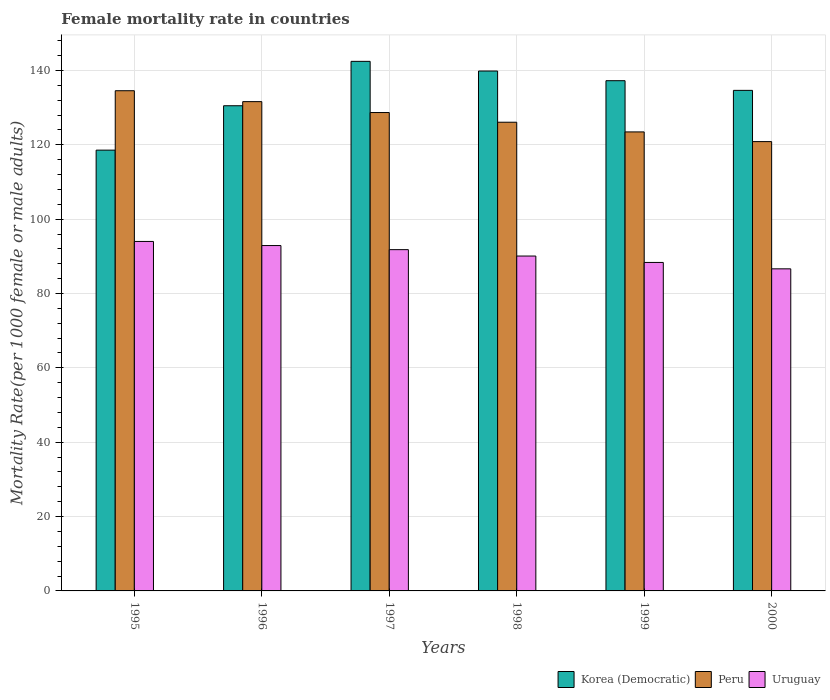How many different coloured bars are there?
Your response must be concise. 3. How many groups of bars are there?
Your answer should be compact. 6. Are the number of bars per tick equal to the number of legend labels?
Make the answer very short. Yes. How many bars are there on the 5th tick from the right?
Your answer should be compact. 3. What is the label of the 1st group of bars from the left?
Give a very brief answer. 1995. In how many cases, is the number of bars for a given year not equal to the number of legend labels?
Make the answer very short. 0. What is the female mortality rate in Peru in 1996?
Ensure brevity in your answer.  131.61. Across all years, what is the maximum female mortality rate in Peru?
Give a very brief answer. 134.54. Across all years, what is the minimum female mortality rate in Peru?
Give a very brief answer. 120.86. In which year was the female mortality rate in Korea (Democratic) maximum?
Give a very brief answer. 1997. In which year was the female mortality rate in Korea (Democratic) minimum?
Offer a terse response. 1995. What is the total female mortality rate in Korea (Democratic) in the graph?
Your answer should be very brief. 803.24. What is the difference between the female mortality rate in Uruguay in 1998 and that in 1999?
Provide a succinct answer. 1.72. What is the difference between the female mortality rate in Korea (Democratic) in 2000 and the female mortality rate in Peru in 1996?
Your answer should be very brief. 3.03. What is the average female mortality rate in Peru per year?
Make the answer very short. 127.54. In the year 1995, what is the difference between the female mortality rate in Korea (Democratic) and female mortality rate in Uruguay?
Provide a succinct answer. 24.56. What is the ratio of the female mortality rate in Uruguay in 1997 to that in 1998?
Provide a succinct answer. 1.02. Is the female mortality rate in Uruguay in 1995 less than that in 1997?
Provide a succinct answer. No. Is the difference between the female mortality rate in Korea (Democratic) in 1995 and 1998 greater than the difference between the female mortality rate in Uruguay in 1995 and 1998?
Your answer should be compact. No. What is the difference between the highest and the second highest female mortality rate in Uruguay?
Make the answer very short. 1.1. What is the difference between the highest and the lowest female mortality rate in Korea (Democratic)?
Offer a very short reply. 23.88. In how many years, is the female mortality rate in Uruguay greater than the average female mortality rate in Uruguay taken over all years?
Give a very brief answer. 3. Is the sum of the female mortality rate in Peru in 1995 and 2000 greater than the maximum female mortality rate in Uruguay across all years?
Make the answer very short. Yes. How many bars are there?
Provide a succinct answer. 18. Are the values on the major ticks of Y-axis written in scientific E-notation?
Give a very brief answer. No. Where does the legend appear in the graph?
Provide a succinct answer. Bottom right. What is the title of the graph?
Keep it short and to the point. Female mortality rate in countries. Does "Iraq" appear as one of the legend labels in the graph?
Your response must be concise. No. What is the label or title of the X-axis?
Provide a short and direct response. Years. What is the label or title of the Y-axis?
Offer a terse response. Mortality Rate(per 1000 female or male adults). What is the Mortality Rate(per 1000 female or male adults) of Korea (Democratic) in 1995?
Give a very brief answer. 118.56. What is the Mortality Rate(per 1000 female or male adults) in Peru in 1995?
Give a very brief answer. 134.54. What is the Mortality Rate(per 1000 female or male adults) of Uruguay in 1995?
Offer a terse response. 94. What is the Mortality Rate(per 1000 female or male adults) in Korea (Democratic) in 1996?
Your response must be concise. 130.5. What is the Mortality Rate(per 1000 female or male adults) in Peru in 1996?
Make the answer very short. 131.61. What is the Mortality Rate(per 1000 female or male adults) in Uruguay in 1996?
Your response must be concise. 92.9. What is the Mortality Rate(per 1000 female or male adults) in Korea (Democratic) in 1997?
Offer a terse response. 142.44. What is the Mortality Rate(per 1000 female or male adults) of Peru in 1997?
Provide a short and direct response. 128.68. What is the Mortality Rate(per 1000 female or male adults) of Uruguay in 1997?
Make the answer very short. 91.8. What is the Mortality Rate(per 1000 female or male adults) of Korea (Democratic) in 1998?
Your response must be concise. 139.84. What is the Mortality Rate(per 1000 female or male adults) in Peru in 1998?
Make the answer very short. 126.07. What is the Mortality Rate(per 1000 female or male adults) in Uruguay in 1998?
Keep it short and to the point. 90.08. What is the Mortality Rate(per 1000 female or male adults) in Korea (Democratic) in 1999?
Ensure brevity in your answer.  137.24. What is the Mortality Rate(per 1000 female or male adults) of Peru in 1999?
Provide a succinct answer. 123.47. What is the Mortality Rate(per 1000 female or male adults) of Uruguay in 1999?
Give a very brief answer. 88.36. What is the Mortality Rate(per 1000 female or male adults) in Korea (Democratic) in 2000?
Keep it short and to the point. 134.64. What is the Mortality Rate(per 1000 female or male adults) in Peru in 2000?
Your answer should be compact. 120.86. What is the Mortality Rate(per 1000 female or male adults) of Uruguay in 2000?
Keep it short and to the point. 86.64. Across all years, what is the maximum Mortality Rate(per 1000 female or male adults) in Korea (Democratic)?
Give a very brief answer. 142.44. Across all years, what is the maximum Mortality Rate(per 1000 female or male adults) of Peru?
Give a very brief answer. 134.54. Across all years, what is the maximum Mortality Rate(per 1000 female or male adults) in Uruguay?
Your answer should be very brief. 94. Across all years, what is the minimum Mortality Rate(per 1000 female or male adults) of Korea (Democratic)?
Provide a short and direct response. 118.56. Across all years, what is the minimum Mortality Rate(per 1000 female or male adults) in Peru?
Give a very brief answer. 120.86. Across all years, what is the minimum Mortality Rate(per 1000 female or male adults) of Uruguay?
Offer a very short reply. 86.64. What is the total Mortality Rate(per 1000 female or male adults) of Korea (Democratic) in the graph?
Your answer should be very brief. 803.24. What is the total Mortality Rate(per 1000 female or male adults) of Peru in the graph?
Your response must be concise. 765.23. What is the total Mortality Rate(per 1000 female or male adults) in Uruguay in the graph?
Your answer should be very brief. 543.76. What is the difference between the Mortality Rate(per 1000 female or male adults) of Korea (Democratic) in 1995 and that in 1996?
Your answer should be compact. -11.94. What is the difference between the Mortality Rate(per 1000 female or male adults) of Peru in 1995 and that in 1996?
Offer a very short reply. 2.93. What is the difference between the Mortality Rate(per 1000 female or male adults) of Uruguay in 1995 and that in 1996?
Your answer should be compact. 1.1. What is the difference between the Mortality Rate(per 1000 female or male adults) of Korea (Democratic) in 1995 and that in 1997?
Your response must be concise. -23.88. What is the difference between the Mortality Rate(per 1000 female or male adults) of Peru in 1995 and that in 1997?
Keep it short and to the point. 5.87. What is the difference between the Mortality Rate(per 1000 female or male adults) in Uruguay in 1995 and that in 1997?
Ensure brevity in your answer.  2.21. What is the difference between the Mortality Rate(per 1000 female or male adults) in Korea (Democratic) in 1995 and that in 1998?
Ensure brevity in your answer.  -21.28. What is the difference between the Mortality Rate(per 1000 female or male adults) of Peru in 1995 and that in 1998?
Your response must be concise. 8.47. What is the difference between the Mortality Rate(per 1000 female or male adults) in Uruguay in 1995 and that in 1998?
Provide a succinct answer. 3.93. What is the difference between the Mortality Rate(per 1000 female or male adults) in Korea (Democratic) in 1995 and that in 1999?
Offer a terse response. -18.68. What is the difference between the Mortality Rate(per 1000 female or male adults) in Peru in 1995 and that in 1999?
Your answer should be very brief. 11.08. What is the difference between the Mortality Rate(per 1000 female or male adults) of Uruguay in 1995 and that in 1999?
Offer a terse response. 5.65. What is the difference between the Mortality Rate(per 1000 female or male adults) in Korea (Democratic) in 1995 and that in 2000?
Offer a very short reply. -16.08. What is the difference between the Mortality Rate(per 1000 female or male adults) of Peru in 1995 and that in 2000?
Make the answer very short. 13.68. What is the difference between the Mortality Rate(per 1000 female or male adults) of Uruguay in 1995 and that in 2000?
Give a very brief answer. 7.37. What is the difference between the Mortality Rate(per 1000 female or male adults) in Korea (Democratic) in 1996 and that in 1997?
Keep it short and to the point. -11.94. What is the difference between the Mortality Rate(per 1000 female or male adults) in Peru in 1996 and that in 1997?
Offer a terse response. 2.93. What is the difference between the Mortality Rate(per 1000 female or male adults) of Uruguay in 1996 and that in 1997?
Give a very brief answer. 1.1. What is the difference between the Mortality Rate(per 1000 female or male adults) in Korea (Democratic) in 1996 and that in 1998?
Ensure brevity in your answer.  -9.34. What is the difference between the Mortality Rate(per 1000 female or male adults) of Peru in 1996 and that in 1998?
Provide a short and direct response. 5.54. What is the difference between the Mortality Rate(per 1000 female or male adults) in Uruguay in 1996 and that in 1998?
Make the answer very short. 2.82. What is the difference between the Mortality Rate(per 1000 female or male adults) of Korea (Democratic) in 1996 and that in 1999?
Your answer should be very brief. -6.74. What is the difference between the Mortality Rate(per 1000 female or male adults) of Peru in 1996 and that in 1999?
Your answer should be very brief. 8.14. What is the difference between the Mortality Rate(per 1000 female or male adults) of Uruguay in 1996 and that in 1999?
Offer a terse response. 4.54. What is the difference between the Mortality Rate(per 1000 female or male adults) of Korea (Democratic) in 1996 and that in 2000?
Your response must be concise. -4.14. What is the difference between the Mortality Rate(per 1000 female or male adults) of Peru in 1996 and that in 2000?
Keep it short and to the point. 10.75. What is the difference between the Mortality Rate(per 1000 female or male adults) of Uruguay in 1996 and that in 2000?
Give a very brief answer. 6.26. What is the difference between the Mortality Rate(per 1000 female or male adults) of Korea (Democratic) in 1997 and that in 1998?
Your answer should be very brief. 2.6. What is the difference between the Mortality Rate(per 1000 female or male adults) in Peru in 1997 and that in 1998?
Provide a short and direct response. 2.6. What is the difference between the Mortality Rate(per 1000 female or male adults) in Uruguay in 1997 and that in 1998?
Your answer should be very brief. 1.72. What is the difference between the Mortality Rate(per 1000 female or male adults) in Korea (Democratic) in 1997 and that in 1999?
Give a very brief answer. 5.2. What is the difference between the Mortality Rate(per 1000 female or male adults) of Peru in 1997 and that in 1999?
Provide a short and direct response. 5.21. What is the difference between the Mortality Rate(per 1000 female or male adults) of Uruguay in 1997 and that in 1999?
Your answer should be compact. 3.44. What is the difference between the Mortality Rate(per 1000 female or male adults) of Korea (Democratic) in 1997 and that in 2000?
Your answer should be very brief. 7.8. What is the difference between the Mortality Rate(per 1000 female or male adults) in Peru in 1997 and that in 2000?
Give a very brief answer. 7.82. What is the difference between the Mortality Rate(per 1000 female or male adults) of Uruguay in 1997 and that in 2000?
Your answer should be compact. 5.16. What is the difference between the Mortality Rate(per 1000 female or male adults) in Korea (Democratic) in 1998 and that in 1999?
Ensure brevity in your answer.  2.6. What is the difference between the Mortality Rate(per 1000 female or male adults) in Peru in 1998 and that in 1999?
Offer a terse response. 2.61. What is the difference between the Mortality Rate(per 1000 female or male adults) of Uruguay in 1998 and that in 1999?
Your response must be concise. 1.72. What is the difference between the Mortality Rate(per 1000 female or male adults) in Korea (Democratic) in 1998 and that in 2000?
Your answer should be very brief. 5.2. What is the difference between the Mortality Rate(per 1000 female or male adults) of Peru in 1998 and that in 2000?
Provide a short and direct response. 5.21. What is the difference between the Mortality Rate(per 1000 female or male adults) in Uruguay in 1998 and that in 2000?
Your response must be concise. 3.44. What is the difference between the Mortality Rate(per 1000 female or male adults) in Korea (Democratic) in 1999 and that in 2000?
Your response must be concise. 2.6. What is the difference between the Mortality Rate(per 1000 female or male adults) of Peru in 1999 and that in 2000?
Give a very brief answer. 2.6. What is the difference between the Mortality Rate(per 1000 female or male adults) in Uruguay in 1999 and that in 2000?
Your answer should be very brief. 1.72. What is the difference between the Mortality Rate(per 1000 female or male adults) of Korea (Democratic) in 1995 and the Mortality Rate(per 1000 female or male adults) of Peru in 1996?
Ensure brevity in your answer.  -13.04. What is the difference between the Mortality Rate(per 1000 female or male adults) in Korea (Democratic) in 1995 and the Mortality Rate(per 1000 female or male adults) in Uruguay in 1996?
Your response must be concise. 25.67. What is the difference between the Mortality Rate(per 1000 female or male adults) of Peru in 1995 and the Mortality Rate(per 1000 female or male adults) of Uruguay in 1996?
Keep it short and to the point. 41.65. What is the difference between the Mortality Rate(per 1000 female or male adults) of Korea (Democratic) in 1995 and the Mortality Rate(per 1000 female or male adults) of Peru in 1997?
Offer a terse response. -10.11. What is the difference between the Mortality Rate(per 1000 female or male adults) of Korea (Democratic) in 1995 and the Mortality Rate(per 1000 female or male adults) of Uruguay in 1997?
Provide a succinct answer. 26.77. What is the difference between the Mortality Rate(per 1000 female or male adults) of Peru in 1995 and the Mortality Rate(per 1000 female or male adults) of Uruguay in 1997?
Your response must be concise. 42.75. What is the difference between the Mortality Rate(per 1000 female or male adults) in Korea (Democratic) in 1995 and the Mortality Rate(per 1000 female or male adults) in Peru in 1998?
Make the answer very short. -7.51. What is the difference between the Mortality Rate(per 1000 female or male adults) in Korea (Democratic) in 1995 and the Mortality Rate(per 1000 female or male adults) in Uruguay in 1998?
Your answer should be compact. 28.49. What is the difference between the Mortality Rate(per 1000 female or male adults) of Peru in 1995 and the Mortality Rate(per 1000 female or male adults) of Uruguay in 1998?
Your answer should be compact. 44.47. What is the difference between the Mortality Rate(per 1000 female or male adults) of Korea (Democratic) in 1995 and the Mortality Rate(per 1000 female or male adults) of Peru in 1999?
Your answer should be very brief. -4.9. What is the difference between the Mortality Rate(per 1000 female or male adults) of Korea (Democratic) in 1995 and the Mortality Rate(per 1000 female or male adults) of Uruguay in 1999?
Your answer should be compact. 30.21. What is the difference between the Mortality Rate(per 1000 female or male adults) in Peru in 1995 and the Mortality Rate(per 1000 female or male adults) in Uruguay in 1999?
Give a very brief answer. 46.19. What is the difference between the Mortality Rate(per 1000 female or male adults) of Korea (Democratic) in 1995 and the Mortality Rate(per 1000 female or male adults) of Peru in 2000?
Ensure brevity in your answer.  -2.29. What is the difference between the Mortality Rate(per 1000 female or male adults) in Korea (Democratic) in 1995 and the Mortality Rate(per 1000 female or male adults) in Uruguay in 2000?
Offer a terse response. 31.93. What is the difference between the Mortality Rate(per 1000 female or male adults) in Peru in 1995 and the Mortality Rate(per 1000 female or male adults) in Uruguay in 2000?
Provide a succinct answer. 47.91. What is the difference between the Mortality Rate(per 1000 female or male adults) of Korea (Democratic) in 1996 and the Mortality Rate(per 1000 female or male adults) of Peru in 1997?
Your answer should be very brief. 1.83. What is the difference between the Mortality Rate(per 1000 female or male adults) of Korea (Democratic) in 1996 and the Mortality Rate(per 1000 female or male adults) of Uruguay in 1997?
Keep it short and to the point. 38.71. What is the difference between the Mortality Rate(per 1000 female or male adults) of Peru in 1996 and the Mortality Rate(per 1000 female or male adults) of Uruguay in 1997?
Provide a succinct answer. 39.81. What is the difference between the Mortality Rate(per 1000 female or male adults) in Korea (Democratic) in 1996 and the Mortality Rate(per 1000 female or male adults) in Peru in 1998?
Keep it short and to the point. 4.43. What is the difference between the Mortality Rate(per 1000 female or male adults) in Korea (Democratic) in 1996 and the Mortality Rate(per 1000 female or male adults) in Uruguay in 1998?
Offer a very short reply. 40.43. What is the difference between the Mortality Rate(per 1000 female or male adults) in Peru in 1996 and the Mortality Rate(per 1000 female or male adults) in Uruguay in 1998?
Make the answer very short. 41.53. What is the difference between the Mortality Rate(per 1000 female or male adults) in Korea (Democratic) in 1996 and the Mortality Rate(per 1000 female or male adults) in Peru in 1999?
Offer a terse response. 7.04. What is the difference between the Mortality Rate(per 1000 female or male adults) of Korea (Democratic) in 1996 and the Mortality Rate(per 1000 female or male adults) of Uruguay in 1999?
Offer a very short reply. 42.15. What is the difference between the Mortality Rate(per 1000 female or male adults) of Peru in 1996 and the Mortality Rate(per 1000 female or male adults) of Uruguay in 1999?
Provide a short and direct response. 43.25. What is the difference between the Mortality Rate(per 1000 female or male adults) in Korea (Democratic) in 1996 and the Mortality Rate(per 1000 female or male adults) in Peru in 2000?
Keep it short and to the point. 9.64. What is the difference between the Mortality Rate(per 1000 female or male adults) in Korea (Democratic) in 1996 and the Mortality Rate(per 1000 female or male adults) in Uruguay in 2000?
Provide a short and direct response. 43.87. What is the difference between the Mortality Rate(per 1000 female or male adults) of Peru in 1996 and the Mortality Rate(per 1000 female or male adults) of Uruguay in 2000?
Your answer should be very brief. 44.97. What is the difference between the Mortality Rate(per 1000 female or male adults) in Korea (Democratic) in 1997 and the Mortality Rate(per 1000 female or male adults) in Peru in 1998?
Provide a short and direct response. 16.37. What is the difference between the Mortality Rate(per 1000 female or male adults) of Korea (Democratic) in 1997 and the Mortality Rate(per 1000 female or male adults) of Uruguay in 1998?
Ensure brevity in your answer.  52.37. What is the difference between the Mortality Rate(per 1000 female or male adults) in Peru in 1997 and the Mortality Rate(per 1000 female or male adults) in Uruguay in 1998?
Your answer should be compact. 38.6. What is the difference between the Mortality Rate(per 1000 female or male adults) in Korea (Democratic) in 1997 and the Mortality Rate(per 1000 female or male adults) in Peru in 1999?
Your response must be concise. 18.98. What is the difference between the Mortality Rate(per 1000 female or male adults) of Korea (Democratic) in 1997 and the Mortality Rate(per 1000 female or male adults) of Uruguay in 1999?
Your response must be concise. 54.09. What is the difference between the Mortality Rate(per 1000 female or male adults) in Peru in 1997 and the Mortality Rate(per 1000 female or male adults) in Uruguay in 1999?
Your response must be concise. 40.32. What is the difference between the Mortality Rate(per 1000 female or male adults) in Korea (Democratic) in 1997 and the Mortality Rate(per 1000 female or male adults) in Peru in 2000?
Your answer should be very brief. 21.59. What is the difference between the Mortality Rate(per 1000 female or male adults) of Korea (Democratic) in 1997 and the Mortality Rate(per 1000 female or male adults) of Uruguay in 2000?
Your answer should be very brief. 55.81. What is the difference between the Mortality Rate(per 1000 female or male adults) of Peru in 1997 and the Mortality Rate(per 1000 female or male adults) of Uruguay in 2000?
Provide a short and direct response. 42.04. What is the difference between the Mortality Rate(per 1000 female or male adults) of Korea (Democratic) in 1998 and the Mortality Rate(per 1000 female or male adults) of Peru in 1999?
Offer a very short reply. 16.38. What is the difference between the Mortality Rate(per 1000 female or male adults) in Korea (Democratic) in 1998 and the Mortality Rate(per 1000 female or male adults) in Uruguay in 1999?
Your answer should be very brief. 51.49. What is the difference between the Mortality Rate(per 1000 female or male adults) in Peru in 1998 and the Mortality Rate(per 1000 female or male adults) in Uruguay in 1999?
Your answer should be very brief. 37.72. What is the difference between the Mortality Rate(per 1000 female or male adults) in Korea (Democratic) in 1998 and the Mortality Rate(per 1000 female or male adults) in Peru in 2000?
Provide a succinct answer. 18.98. What is the difference between the Mortality Rate(per 1000 female or male adults) in Korea (Democratic) in 1998 and the Mortality Rate(per 1000 female or male adults) in Uruguay in 2000?
Your response must be concise. 53.21. What is the difference between the Mortality Rate(per 1000 female or male adults) in Peru in 1998 and the Mortality Rate(per 1000 female or male adults) in Uruguay in 2000?
Keep it short and to the point. 39.43. What is the difference between the Mortality Rate(per 1000 female or male adults) in Korea (Democratic) in 1999 and the Mortality Rate(per 1000 female or male adults) in Peru in 2000?
Your response must be concise. 16.38. What is the difference between the Mortality Rate(per 1000 female or male adults) of Korea (Democratic) in 1999 and the Mortality Rate(per 1000 female or male adults) of Uruguay in 2000?
Offer a terse response. 50.6. What is the difference between the Mortality Rate(per 1000 female or male adults) in Peru in 1999 and the Mortality Rate(per 1000 female or male adults) in Uruguay in 2000?
Provide a short and direct response. 36.83. What is the average Mortality Rate(per 1000 female or male adults) of Korea (Democratic) per year?
Your response must be concise. 133.87. What is the average Mortality Rate(per 1000 female or male adults) of Peru per year?
Provide a short and direct response. 127.54. What is the average Mortality Rate(per 1000 female or male adults) of Uruguay per year?
Your answer should be compact. 90.63. In the year 1995, what is the difference between the Mortality Rate(per 1000 female or male adults) of Korea (Democratic) and Mortality Rate(per 1000 female or male adults) of Peru?
Provide a succinct answer. -15.98. In the year 1995, what is the difference between the Mortality Rate(per 1000 female or male adults) of Korea (Democratic) and Mortality Rate(per 1000 female or male adults) of Uruguay?
Give a very brief answer. 24.56. In the year 1995, what is the difference between the Mortality Rate(per 1000 female or male adults) in Peru and Mortality Rate(per 1000 female or male adults) in Uruguay?
Offer a very short reply. 40.54. In the year 1996, what is the difference between the Mortality Rate(per 1000 female or male adults) in Korea (Democratic) and Mortality Rate(per 1000 female or male adults) in Peru?
Your answer should be compact. -1.1. In the year 1996, what is the difference between the Mortality Rate(per 1000 female or male adults) of Korea (Democratic) and Mortality Rate(per 1000 female or male adults) of Uruguay?
Keep it short and to the point. 37.61. In the year 1996, what is the difference between the Mortality Rate(per 1000 female or male adults) of Peru and Mortality Rate(per 1000 female or male adults) of Uruguay?
Make the answer very short. 38.71. In the year 1997, what is the difference between the Mortality Rate(per 1000 female or male adults) of Korea (Democratic) and Mortality Rate(per 1000 female or male adults) of Peru?
Offer a terse response. 13.77. In the year 1997, what is the difference between the Mortality Rate(per 1000 female or male adults) of Korea (Democratic) and Mortality Rate(per 1000 female or male adults) of Uruguay?
Keep it short and to the point. 50.65. In the year 1997, what is the difference between the Mortality Rate(per 1000 female or male adults) of Peru and Mortality Rate(per 1000 female or male adults) of Uruguay?
Your answer should be compact. 36.88. In the year 1998, what is the difference between the Mortality Rate(per 1000 female or male adults) of Korea (Democratic) and Mortality Rate(per 1000 female or male adults) of Peru?
Keep it short and to the point. 13.77. In the year 1998, what is the difference between the Mortality Rate(per 1000 female or male adults) of Korea (Democratic) and Mortality Rate(per 1000 female or male adults) of Uruguay?
Provide a short and direct response. 49.77. In the year 1998, what is the difference between the Mortality Rate(per 1000 female or male adults) in Peru and Mortality Rate(per 1000 female or male adults) in Uruguay?
Your response must be concise. 35.99. In the year 1999, what is the difference between the Mortality Rate(per 1000 female or male adults) in Korea (Democratic) and Mortality Rate(per 1000 female or male adults) in Peru?
Keep it short and to the point. 13.78. In the year 1999, what is the difference between the Mortality Rate(per 1000 female or male adults) in Korea (Democratic) and Mortality Rate(per 1000 female or male adults) in Uruguay?
Provide a succinct answer. 48.89. In the year 1999, what is the difference between the Mortality Rate(per 1000 female or male adults) of Peru and Mortality Rate(per 1000 female or male adults) of Uruguay?
Offer a terse response. 35.11. In the year 2000, what is the difference between the Mortality Rate(per 1000 female or male adults) of Korea (Democratic) and Mortality Rate(per 1000 female or male adults) of Peru?
Offer a very short reply. 13.78. In the year 2000, what is the difference between the Mortality Rate(per 1000 female or male adults) in Korea (Democratic) and Mortality Rate(per 1000 female or male adults) in Uruguay?
Keep it short and to the point. 48. In the year 2000, what is the difference between the Mortality Rate(per 1000 female or male adults) of Peru and Mortality Rate(per 1000 female or male adults) of Uruguay?
Ensure brevity in your answer.  34.22. What is the ratio of the Mortality Rate(per 1000 female or male adults) of Korea (Democratic) in 1995 to that in 1996?
Ensure brevity in your answer.  0.91. What is the ratio of the Mortality Rate(per 1000 female or male adults) of Peru in 1995 to that in 1996?
Your response must be concise. 1.02. What is the ratio of the Mortality Rate(per 1000 female or male adults) of Uruguay in 1995 to that in 1996?
Provide a succinct answer. 1.01. What is the ratio of the Mortality Rate(per 1000 female or male adults) in Korea (Democratic) in 1995 to that in 1997?
Provide a succinct answer. 0.83. What is the ratio of the Mortality Rate(per 1000 female or male adults) in Peru in 1995 to that in 1997?
Your response must be concise. 1.05. What is the ratio of the Mortality Rate(per 1000 female or male adults) in Korea (Democratic) in 1995 to that in 1998?
Offer a terse response. 0.85. What is the ratio of the Mortality Rate(per 1000 female or male adults) in Peru in 1995 to that in 1998?
Provide a succinct answer. 1.07. What is the ratio of the Mortality Rate(per 1000 female or male adults) of Uruguay in 1995 to that in 1998?
Provide a short and direct response. 1.04. What is the ratio of the Mortality Rate(per 1000 female or male adults) in Korea (Democratic) in 1995 to that in 1999?
Your response must be concise. 0.86. What is the ratio of the Mortality Rate(per 1000 female or male adults) in Peru in 1995 to that in 1999?
Make the answer very short. 1.09. What is the ratio of the Mortality Rate(per 1000 female or male adults) in Uruguay in 1995 to that in 1999?
Your response must be concise. 1.06. What is the ratio of the Mortality Rate(per 1000 female or male adults) in Korea (Democratic) in 1995 to that in 2000?
Ensure brevity in your answer.  0.88. What is the ratio of the Mortality Rate(per 1000 female or male adults) of Peru in 1995 to that in 2000?
Provide a succinct answer. 1.11. What is the ratio of the Mortality Rate(per 1000 female or male adults) of Uruguay in 1995 to that in 2000?
Offer a very short reply. 1.08. What is the ratio of the Mortality Rate(per 1000 female or male adults) of Korea (Democratic) in 1996 to that in 1997?
Offer a very short reply. 0.92. What is the ratio of the Mortality Rate(per 1000 female or male adults) of Peru in 1996 to that in 1997?
Offer a terse response. 1.02. What is the ratio of the Mortality Rate(per 1000 female or male adults) in Uruguay in 1996 to that in 1997?
Provide a succinct answer. 1.01. What is the ratio of the Mortality Rate(per 1000 female or male adults) in Korea (Democratic) in 1996 to that in 1998?
Offer a terse response. 0.93. What is the ratio of the Mortality Rate(per 1000 female or male adults) of Peru in 1996 to that in 1998?
Your answer should be very brief. 1.04. What is the ratio of the Mortality Rate(per 1000 female or male adults) in Uruguay in 1996 to that in 1998?
Provide a succinct answer. 1.03. What is the ratio of the Mortality Rate(per 1000 female or male adults) in Korea (Democratic) in 1996 to that in 1999?
Ensure brevity in your answer.  0.95. What is the ratio of the Mortality Rate(per 1000 female or male adults) in Peru in 1996 to that in 1999?
Your answer should be compact. 1.07. What is the ratio of the Mortality Rate(per 1000 female or male adults) of Uruguay in 1996 to that in 1999?
Provide a short and direct response. 1.05. What is the ratio of the Mortality Rate(per 1000 female or male adults) of Korea (Democratic) in 1996 to that in 2000?
Provide a succinct answer. 0.97. What is the ratio of the Mortality Rate(per 1000 female or male adults) in Peru in 1996 to that in 2000?
Your answer should be compact. 1.09. What is the ratio of the Mortality Rate(per 1000 female or male adults) in Uruguay in 1996 to that in 2000?
Provide a short and direct response. 1.07. What is the ratio of the Mortality Rate(per 1000 female or male adults) of Korea (Democratic) in 1997 to that in 1998?
Offer a very short reply. 1.02. What is the ratio of the Mortality Rate(per 1000 female or male adults) in Peru in 1997 to that in 1998?
Give a very brief answer. 1.02. What is the ratio of the Mortality Rate(per 1000 female or male adults) of Uruguay in 1997 to that in 1998?
Ensure brevity in your answer.  1.02. What is the ratio of the Mortality Rate(per 1000 female or male adults) of Korea (Democratic) in 1997 to that in 1999?
Your answer should be compact. 1.04. What is the ratio of the Mortality Rate(per 1000 female or male adults) in Peru in 1997 to that in 1999?
Your response must be concise. 1.04. What is the ratio of the Mortality Rate(per 1000 female or male adults) in Uruguay in 1997 to that in 1999?
Your answer should be compact. 1.04. What is the ratio of the Mortality Rate(per 1000 female or male adults) of Korea (Democratic) in 1997 to that in 2000?
Your answer should be very brief. 1.06. What is the ratio of the Mortality Rate(per 1000 female or male adults) of Peru in 1997 to that in 2000?
Offer a terse response. 1.06. What is the ratio of the Mortality Rate(per 1000 female or male adults) of Uruguay in 1997 to that in 2000?
Provide a succinct answer. 1.06. What is the ratio of the Mortality Rate(per 1000 female or male adults) in Korea (Democratic) in 1998 to that in 1999?
Make the answer very short. 1.02. What is the ratio of the Mortality Rate(per 1000 female or male adults) in Peru in 1998 to that in 1999?
Your answer should be very brief. 1.02. What is the ratio of the Mortality Rate(per 1000 female or male adults) of Uruguay in 1998 to that in 1999?
Keep it short and to the point. 1.02. What is the ratio of the Mortality Rate(per 1000 female or male adults) of Korea (Democratic) in 1998 to that in 2000?
Offer a very short reply. 1.04. What is the ratio of the Mortality Rate(per 1000 female or male adults) of Peru in 1998 to that in 2000?
Your response must be concise. 1.04. What is the ratio of the Mortality Rate(per 1000 female or male adults) in Uruguay in 1998 to that in 2000?
Provide a succinct answer. 1.04. What is the ratio of the Mortality Rate(per 1000 female or male adults) in Korea (Democratic) in 1999 to that in 2000?
Provide a succinct answer. 1.02. What is the ratio of the Mortality Rate(per 1000 female or male adults) in Peru in 1999 to that in 2000?
Make the answer very short. 1.02. What is the ratio of the Mortality Rate(per 1000 female or male adults) of Uruguay in 1999 to that in 2000?
Ensure brevity in your answer.  1.02. What is the difference between the highest and the second highest Mortality Rate(per 1000 female or male adults) in Korea (Democratic)?
Provide a short and direct response. 2.6. What is the difference between the highest and the second highest Mortality Rate(per 1000 female or male adults) in Peru?
Your answer should be very brief. 2.93. What is the difference between the highest and the second highest Mortality Rate(per 1000 female or male adults) of Uruguay?
Provide a succinct answer. 1.1. What is the difference between the highest and the lowest Mortality Rate(per 1000 female or male adults) of Korea (Democratic)?
Your answer should be compact. 23.88. What is the difference between the highest and the lowest Mortality Rate(per 1000 female or male adults) of Peru?
Offer a terse response. 13.68. What is the difference between the highest and the lowest Mortality Rate(per 1000 female or male adults) in Uruguay?
Offer a terse response. 7.37. 